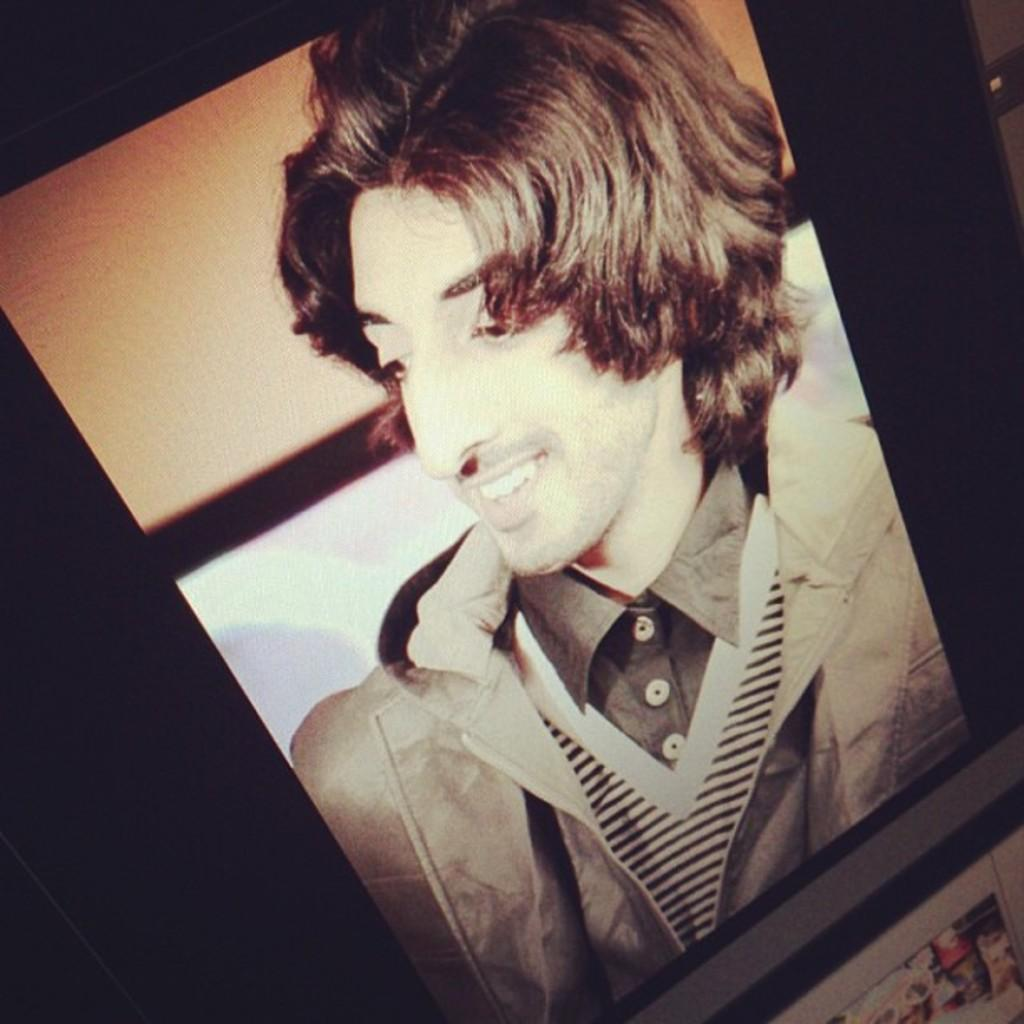What is depicted in the image? There is a picture of a man in the image. How is the man in the image feeling? The man is smiling, which suggests he is happy or content. What type of sack is being used to carry the light in the image? There is no sack or light present in the image; it only features a picture of a man. 